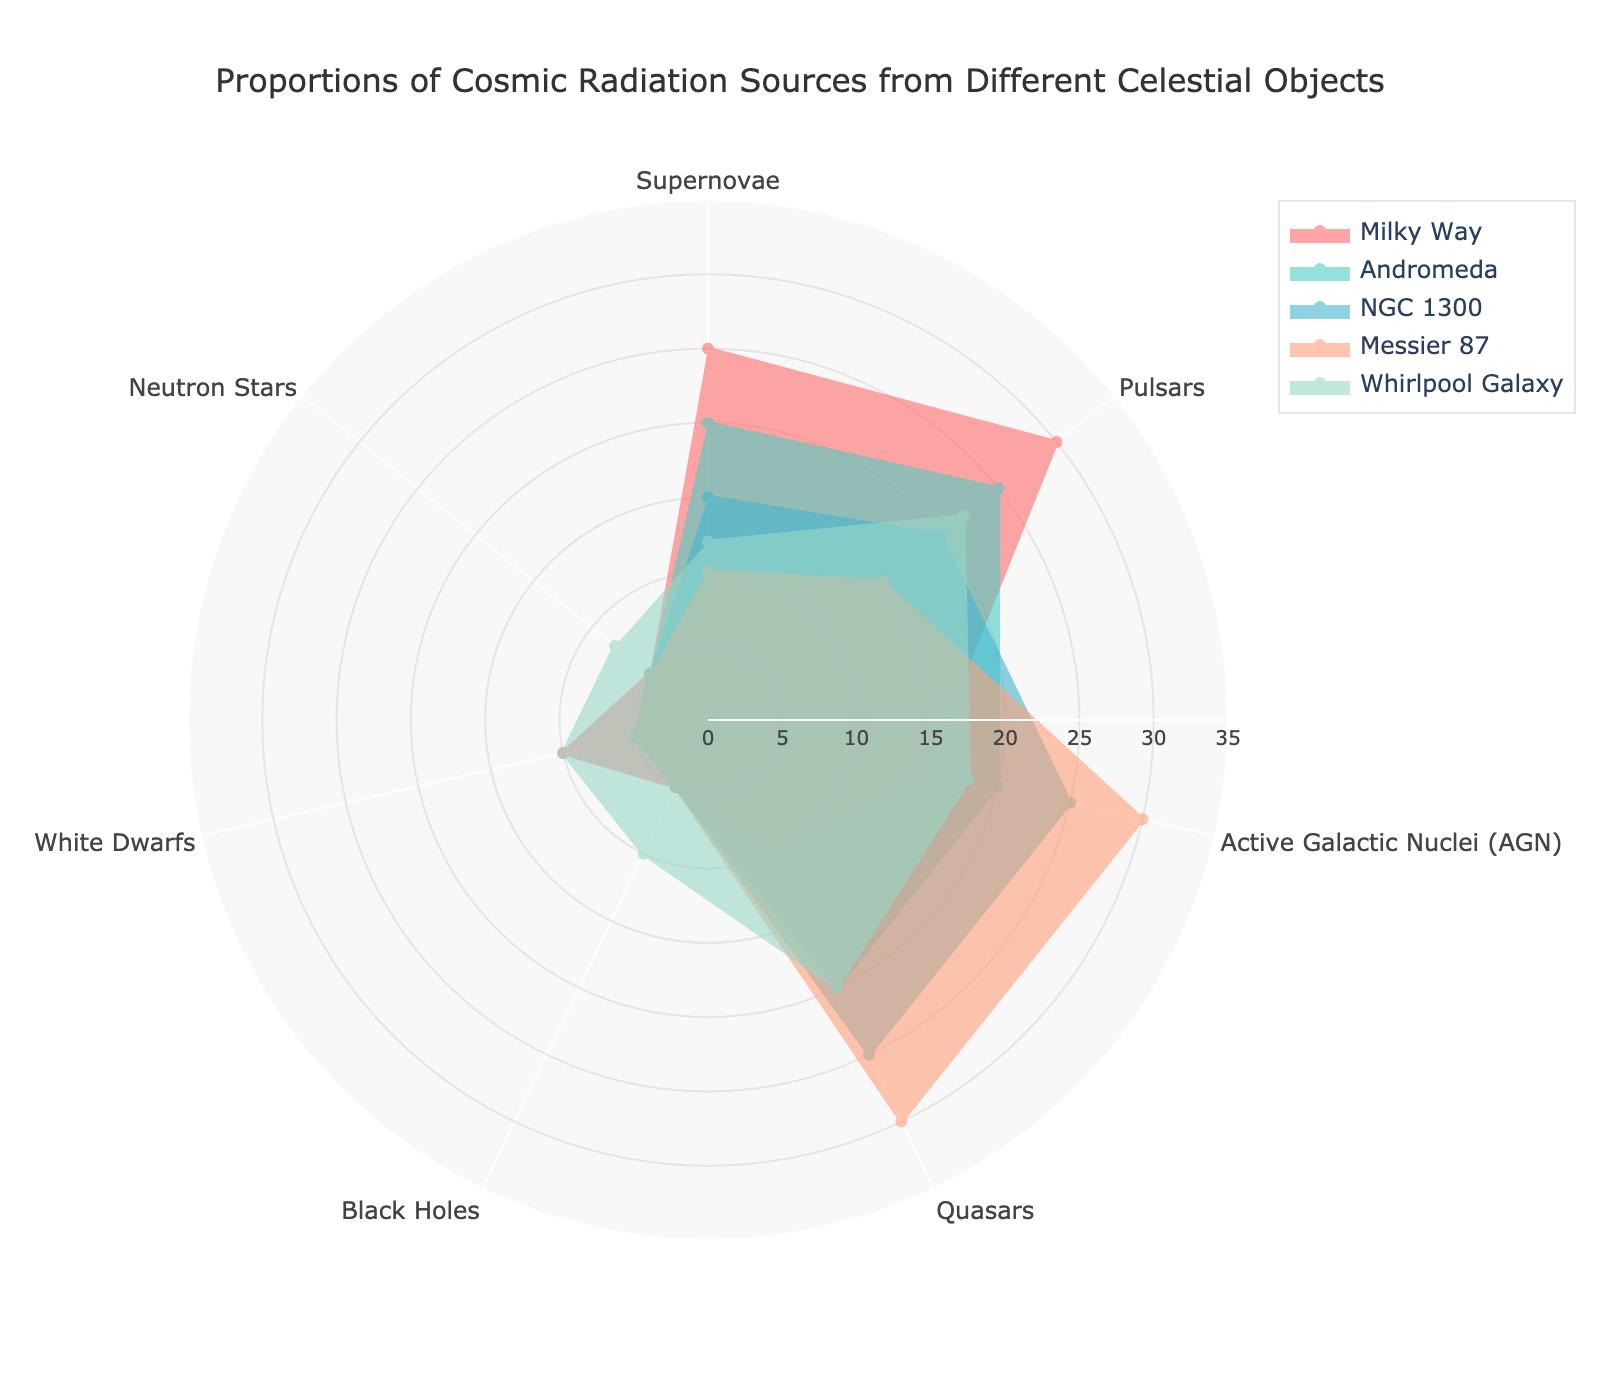What is the largest proportion of cosmic radiation sources from supernovae? By examining the radar chart and looking at the edge labeled "Supernovae," we see that the highest value, which corresponds to the longest spoke, is at 25 for the Milky Way.
Answer: 25 Which celestial object has the highest proportion of cosmic radiation sources from Active Galactic Nuclei (AGN)? Checking each edge labeled "Active Galactic Nuclei (AGN)" across all celestial objects, we find that the longest spoke is 30 for Messier 87.
Answer: Messier 87 What's the sum of the proportions of cosmic radiation sources from quasars for all celestial objects? Adding up the values for "Quasars" from Milky Way (10), Andromeda (20), NGC 1300 (25), Messier 87 (30), and Whirlpool Galaxy (20), we get 10 + 20 + 25 + 30 + 20 = 105.
Answer: 105 Which galaxy has the lowest proportion of cosmic radiation sources from neutron stars? By comparing the "Neutron Stars" edges across all celestial objects, we see that they all have the same value of 5, except for Whirlpool Galaxy which has 8. Therefore, the minimum is 5.
Answer: Milky Way, Andromeda, NGC 1300, Messier 87 How do the cosmic radiation sources from white dwarfs compare between Milky Way and Whirlpool Galaxy? By referring to the radar chart, the Milky Way has a proportion of 10 from white dwarfs, while the Whirlpool Galaxy has the same proportion of 10. Thus, they are equal.
Answer: They are equal What is the overall trend in the proportions of cosmic radiation sources from supernovae across the celestial objects depicted? Observing the "Supernovae" edge, we note that the proportions generally decrease from Milky Way (25) to Andromeda (20), NGC 1300 (15), Messier 87 (10), and then a slight increase in Whirlpool Galaxy (12).
Answer: Generally decreasing Which two celestial objects have the same proportion of cosmic radiation sources from black holes? By checking the radar chart, both Milky Way and Andromeda have the same proportion of 5 from black holes.
Answer: Milky Way and Andromeda What is the average proportion of cosmic radiation sources from pulsars across all celestial objects? Adding the values for "Pulsars" (Milky Way: 30, Andromeda: 25, NGC 1300: 20, Messier 87: 15, Whirlpool Galaxy: 22) results in 30 + 25 + 20 + 15 + 22 = 112. Dividing by 5, the average is 112/5 = 22.4.
Answer: 22.4 